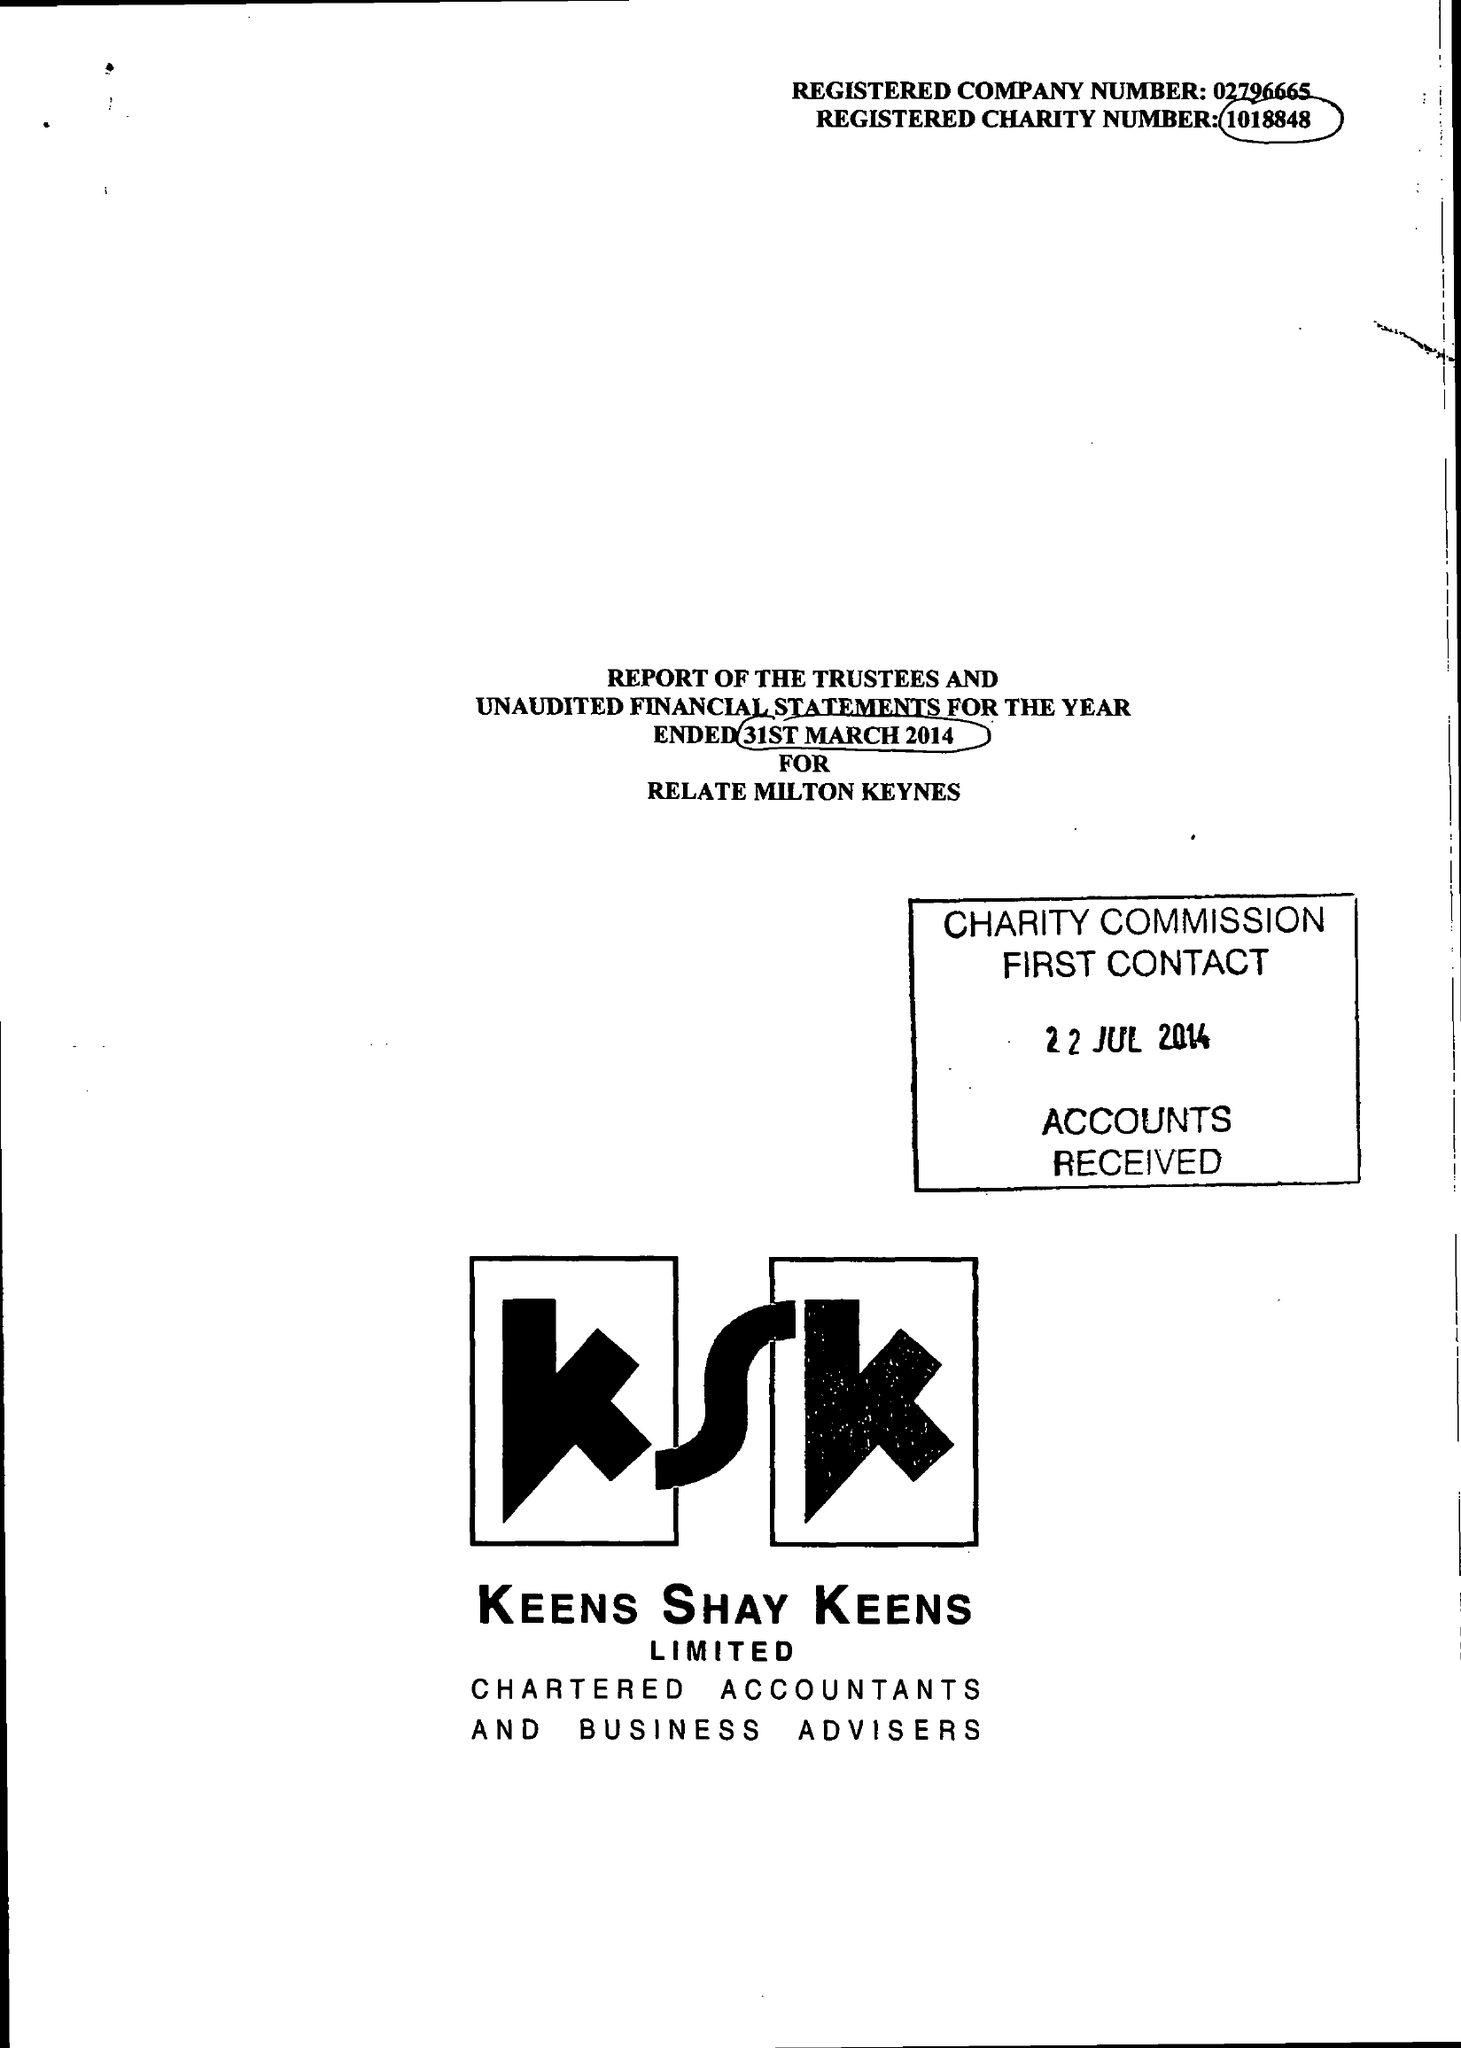What is the value for the address__postcode?
Answer the question using a single word or phrase. MK12 5HX 